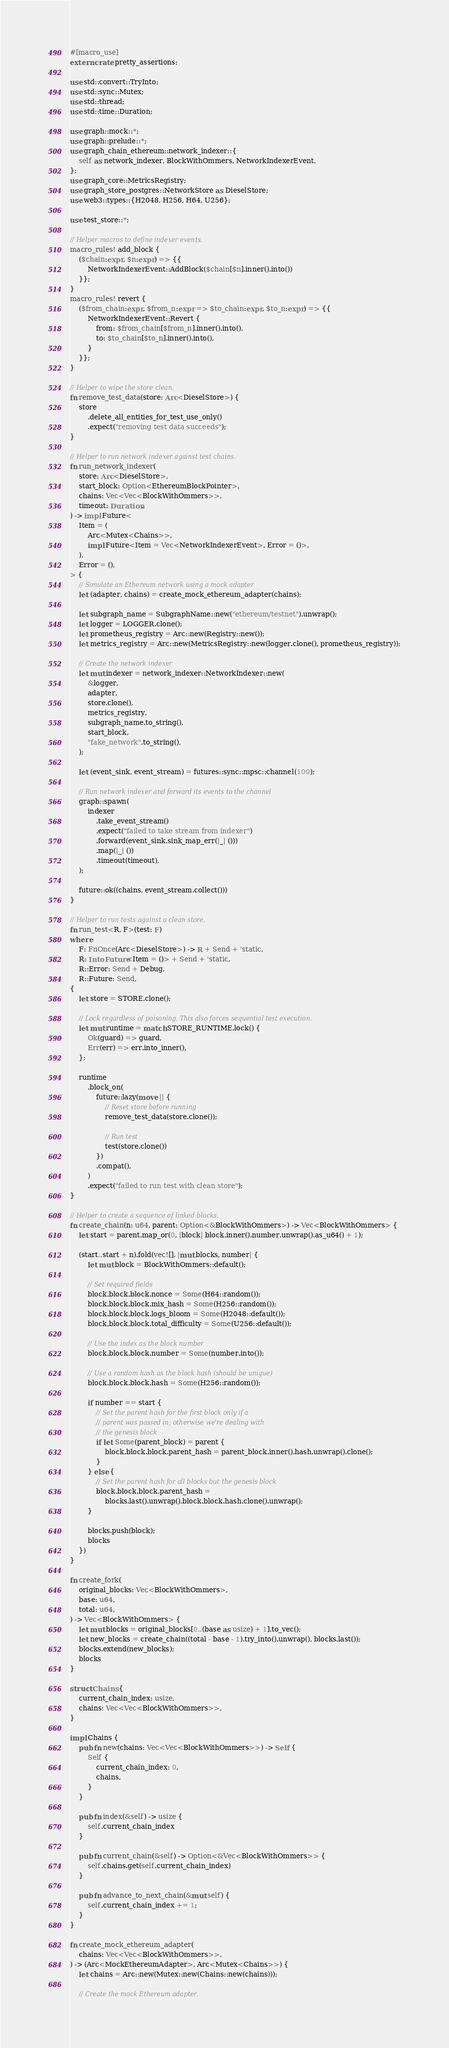Convert code to text. <code><loc_0><loc_0><loc_500><loc_500><_Rust_>#[macro_use]
extern crate pretty_assertions;

use std::convert::TryInto;
use std::sync::Mutex;
use std::thread;
use std::time::Duration;

use graph::mock::*;
use graph::prelude::*;
use graph_chain_ethereum::network_indexer::{
    self as network_indexer, BlockWithOmmers, NetworkIndexerEvent,
};
use graph_core::MetricsRegistry;
use graph_store_postgres::NetworkStore as DieselStore;
use web3::types::{H2048, H256, H64, U256};

use test_store::*;

// Helper macros to define indexer events.
macro_rules! add_block {
    ($chain:expr, $n:expr) => {{
        NetworkIndexerEvent::AddBlock($chain[$n].inner().into())
    }};
}
macro_rules! revert {
    ($from_chain:expr, $from_n:expr => $to_chain:expr, $to_n:expr) => {{
        NetworkIndexerEvent::Revert {
            from: $from_chain[$from_n].inner().into(),
            to: $to_chain[$to_n].inner().into(),
        }
    }};
}

// Helper to wipe the store clean.
fn remove_test_data(store: Arc<DieselStore>) {
    store
        .delete_all_entities_for_test_use_only()
        .expect("removing test data succeeds");
}

// Helper to run network indexer against test chains.
fn run_network_indexer(
    store: Arc<DieselStore>,
    start_block: Option<EthereumBlockPointer>,
    chains: Vec<Vec<BlockWithOmmers>>,
    timeout: Duration,
) -> impl Future<
    Item = (
        Arc<Mutex<Chains>>,
        impl Future<Item = Vec<NetworkIndexerEvent>, Error = ()>,
    ),
    Error = (),
> {
    // Simulate an Ethereum network using a mock adapter
    let (adapter, chains) = create_mock_ethereum_adapter(chains);

    let subgraph_name = SubgraphName::new("ethereum/testnet").unwrap();
    let logger = LOGGER.clone();
    let prometheus_registry = Arc::new(Registry::new());
    let metrics_registry = Arc::new(MetricsRegistry::new(logger.clone(), prometheus_registry));

    // Create the network indexer
    let mut indexer = network_indexer::NetworkIndexer::new(
        &logger,
        adapter,
        store.clone(),
        metrics_registry,
        subgraph_name.to_string(),
        start_block,
        "fake_network".to_string(),
    );

    let (event_sink, event_stream) = futures::sync::mpsc::channel(100);

    // Run network indexer and forward its events to the channel
    graph::spawn(
        indexer
            .take_event_stream()
            .expect("failed to take stream from indexer")
            .forward(event_sink.sink_map_err(|_| ()))
            .map(|_| ())
            .timeout(timeout),
    );

    future::ok((chains, event_stream.collect()))
}

// Helper to run tests against a clean store.
fn run_test<R, F>(test: F)
where
    F: FnOnce(Arc<DieselStore>) -> R + Send + 'static,
    R: IntoFuture<Item = ()> + Send + 'static,
    R::Error: Send + Debug,
    R::Future: Send,
{
    let store = STORE.clone();

    // Lock regardless of poisoning. This also forces sequential test execution.
    let mut runtime = match STORE_RUNTIME.lock() {
        Ok(guard) => guard,
        Err(err) => err.into_inner(),
    };

    runtime
        .block_on(
            future::lazy(move || {
                // Reset store before running
                remove_test_data(store.clone());

                // Run test
                test(store.clone())
            })
            .compat(),
        )
        .expect("failed to run test with clean store");
}

// Helper to create a sequence of linked blocks.
fn create_chain(n: u64, parent: Option<&BlockWithOmmers>) -> Vec<BlockWithOmmers> {
    let start = parent.map_or(0, |block| block.inner().number.unwrap().as_u64() + 1);

    (start..start + n).fold(vec![], |mut blocks, number| {
        let mut block = BlockWithOmmers::default();

        // Set required fields
        block.block.block.nonce = Some(H64::random());
        block.block.block.mix_hash = Some(H256::random());
        block.block.block.logs_bloom = Some(H2048::default());
        block.block.block.total_difficulty = Some(U256::default());

        // Use the index as the block number
        block.block.block.number = Some(number.into());

        // Use a random hash as the block hash (should be unique)
        block.block.block.hash = Some(H256::random());

        if number == start {
            // Set the parent hash for the first block only if a
            // parent was passed in; otherwise we're dealing with
            // the genesis block
            if let Some(parent_block) = parent {
                block.block.block.parent_hash = parent_block.inner().hash.unwrap().clone();
            }
        } else {
            // Set the parent hash for all blocks but the genesis block
            block.block.block.parent_hash =
                blocks.last().unwrap().block.block.hash.clone().unwrap();
        }

        blocks.push(block);
        blocks
    })
}

fn create_fork(
    original_blocks: Vec<BlockWithOmmers>,
    base: u64,
    total: u64,
) -> Vec<BlockWithOmmers> {
    let mut blocks = original_blocks[0..(base as usize) + 1].to_vec();
    let new_blocks = create_chain((total - base - 1).try_into().unwrap(), blocks.last());
    blocks.extend(new_blocks);
    blocks
}

struct Chains {
    current_chain_index: usize,
    chains: Vec<Vec<BlockWithOmmers>>,
}

impl Chains {
    pub fn new(chains: Vec<Vec<BlockWithOmmers>>) -> Self {
        Self {
            current_chain_index: 0,
            chains,
        }
    }

    pub fn index(&self) -> usize {
        self.current_chain_index
    }

    pub fn current_chain(&self) -> Option<&Vec<BlockWithOmmers>> {
        self.chains.get(self.current_chain_index)
    }

    pub fn advance_to_next_chain(&mut self) {
        self.current_chain_index += 1;
    }
}

fn create_mock_ethereum_adapter(
    chains: Vec<Vec<BlockWithOmmers>>,
) -> (Arc<MockEthereumAdapter>, Arc<Mutex<Chains>>) {
    let chains = Arc::new(Mutex::new(Chains::new(chains)));

    // Create the mock Ethereum adapter.</code> 